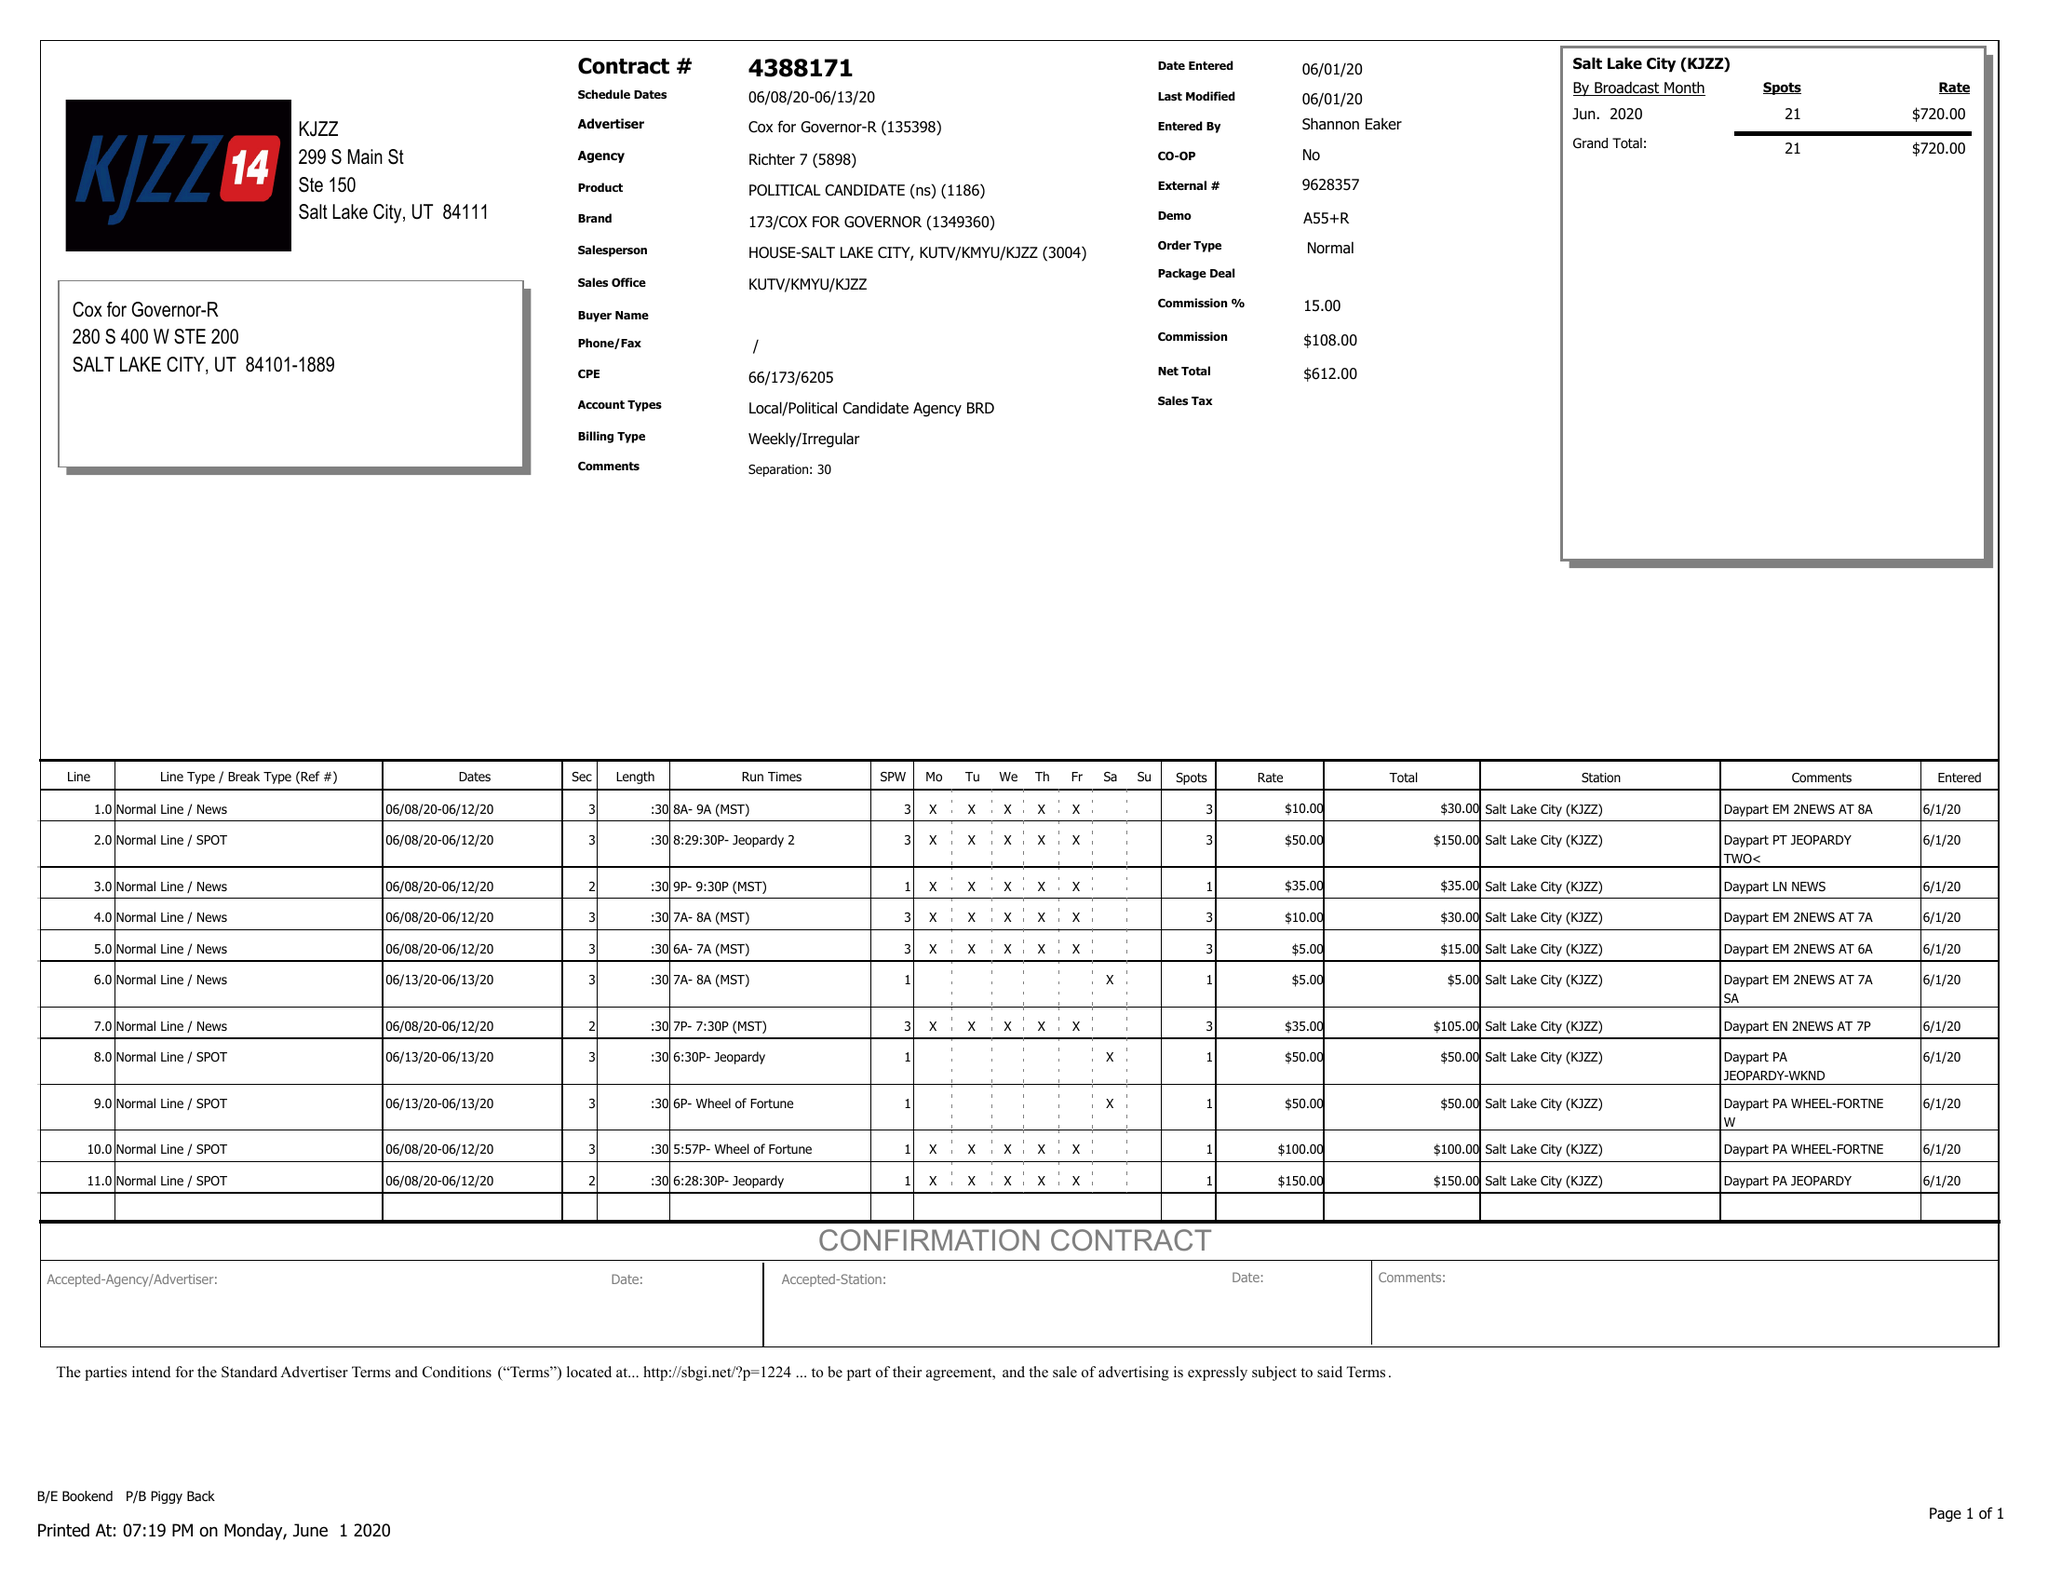What is the value for the flight_from?
Answer the question using a single word or phrase. 06/08/20 